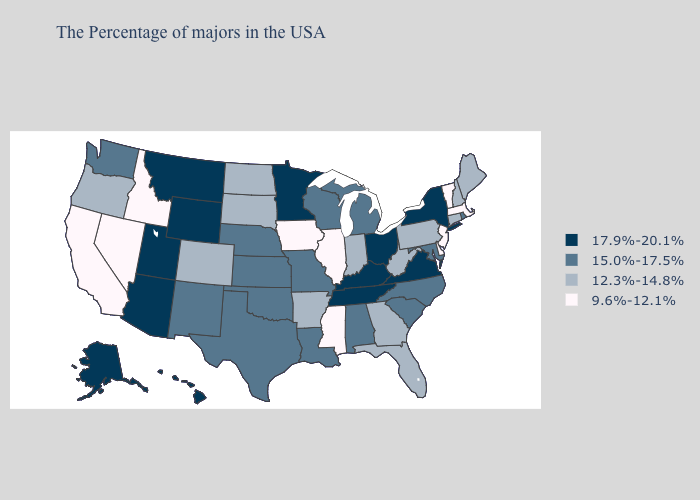Name the states that have a value in the range 17.9%-20.1%?
Write a very short answer. New York, Virginia, Ohio, Kentucky, Tennessee, Minnesota, Wyoming, Utah, Montana, Arizona, Alaska, Hawaii. Name the states that have a value in the range 12.3%-14.8%?
Be succinct. Maine, New Hampshire, Connecticut, Pennsylvania, West Virginia, Florida, Georgia, Indiana, Arkansas, South Dakota, North Dakota, Colorado, Oregon. What is the highest value in the Northeast ?
Give a very brief answer. 17.9%-20.1%. What is the value of South Dakota?
Quick response, please. 12.3%-14.8%. Name the states that have a value in the range 17.9%-20.1%?
Short answer required. New York, Virginia, Ohio, Kentucky, Tennessee, Minnesota, Wyoming, Utah, Montana, Arizona, Alaska, Hawaii. Name the states that have a value in the range 12.3%-14.8%?
Answer briefly. Maine, New Hampshire, Connecticut, Pennsylvania, West Virginia, Florida, Georgia, Indiana, Arkansas, South Dakota, North Dakota, Colorado, Oregon. Does Illinois have a higher value than Utah?
Write a very short answer. No. Does California have a lower value than Nevada?
Give a very brief answer. No. Name the states that have a value in the range 12.3%-14.8%?
Answer briefly. Maine, New Hampshire, Connecticut, Pennsylvania, West Virginia, Florida, Georgia, Indiana, Arkansas, South Dakota, North Dakota, Colorado, Oregon. How many symbols are there in the legend?
Concise answer only. 4. What is the value of Massachusetts?
Give a very brief answer. 9.6%-12.1%. Name the states that have a value in the range 9.6%-12.1%?
Be succinct. Massachusetts, Vermont, New Jersey, Delaware, Illinois, Mississippi, Iowa, Idaho, Nevada, California. Among the states that border Ohio , which have the highest value?
Answer briefly. Kentucky. What is the value of Nebraska?
Keep it brief. 15.0%-17.5%. What is the value of Montana?
Short answer required. 17.9%-20.1%. 